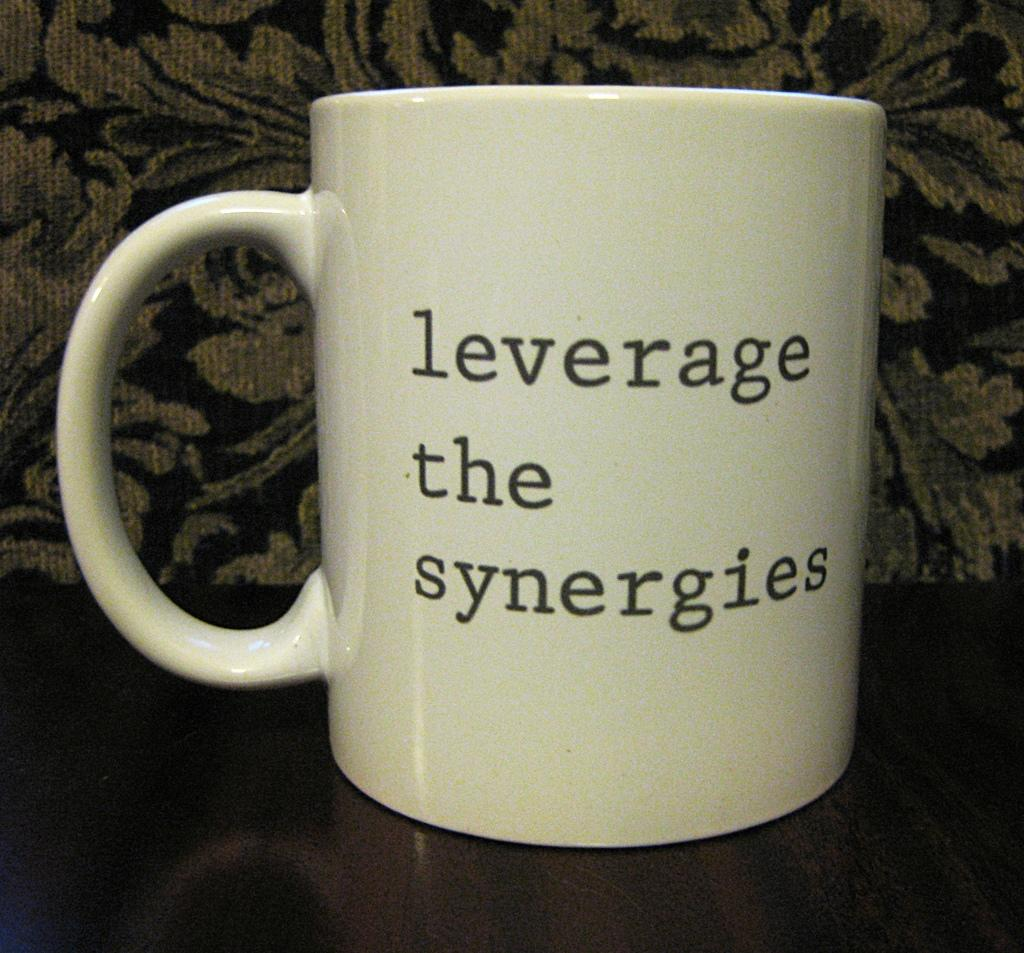<image>
Give a short and clear explanation of the subsequent image. A coffee mug that says leverage the synergies on it. 